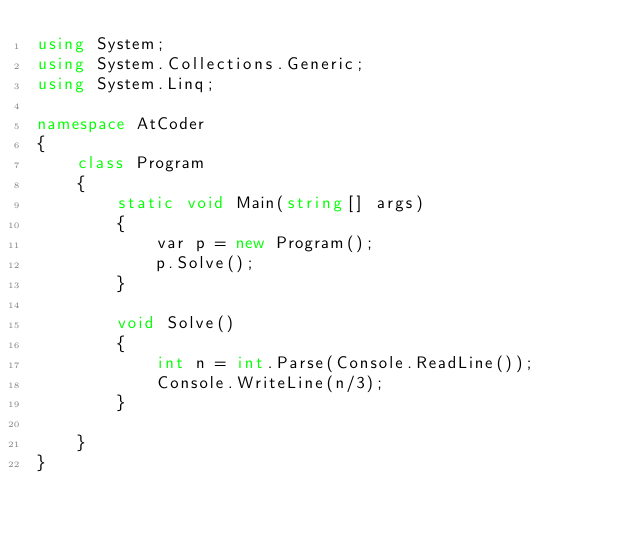Convert code to text. <code><loc_0><loc_0><loc_500><loc_500><_C#_>using System;
using System.Collections.Generic;
using System.Linq;

namespace AtCoder
{
    class Program
    {
        static void Main(string[] args)
        {
            var p = new Program();
            p.Solve();
        }

        void Solve()
        {
            int n = int.Parse(Console.ReadLine());
            Console.WriteLine(n/3);
        }

    }
}
</code> 